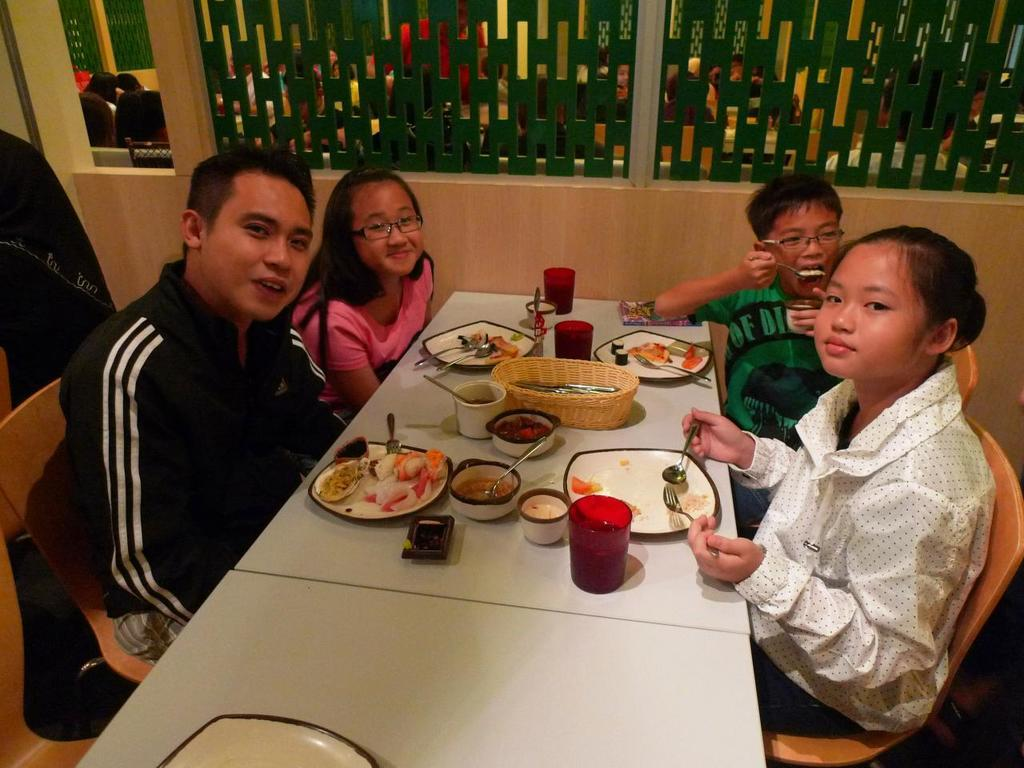What are the people in the image doing? The people in the image are sitting on chairs and eating at a table. How many girls and boys are present in the image? There are two girls and two boys in the image. What is on the table in the image? There is a table in the image with plates, bowls, glasses, and spoons on it. What type of art is hanging on the wall behind the table in the image? There is no art visible on the wall behind the table in the image. What kind of jewel is being used as a centerpiece on the table? There is no jewel present on the table in the image. 